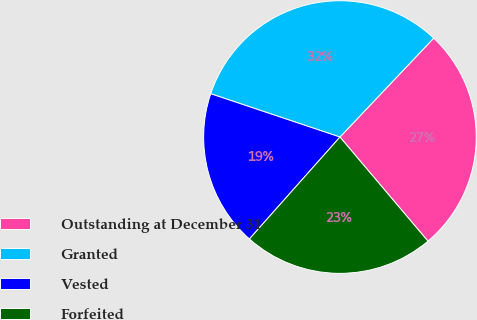<chart> <loc_0><loc_0><loc_500><loc_500><pie_chart><fcel>Outstanding at December 31<fcel>Granted<fcel>Vested<fcel>Forfeited<nl><fcel>26.76%<fcel>31.93%<fcel>18.59%<fcel>22.73%<nl></chart> 